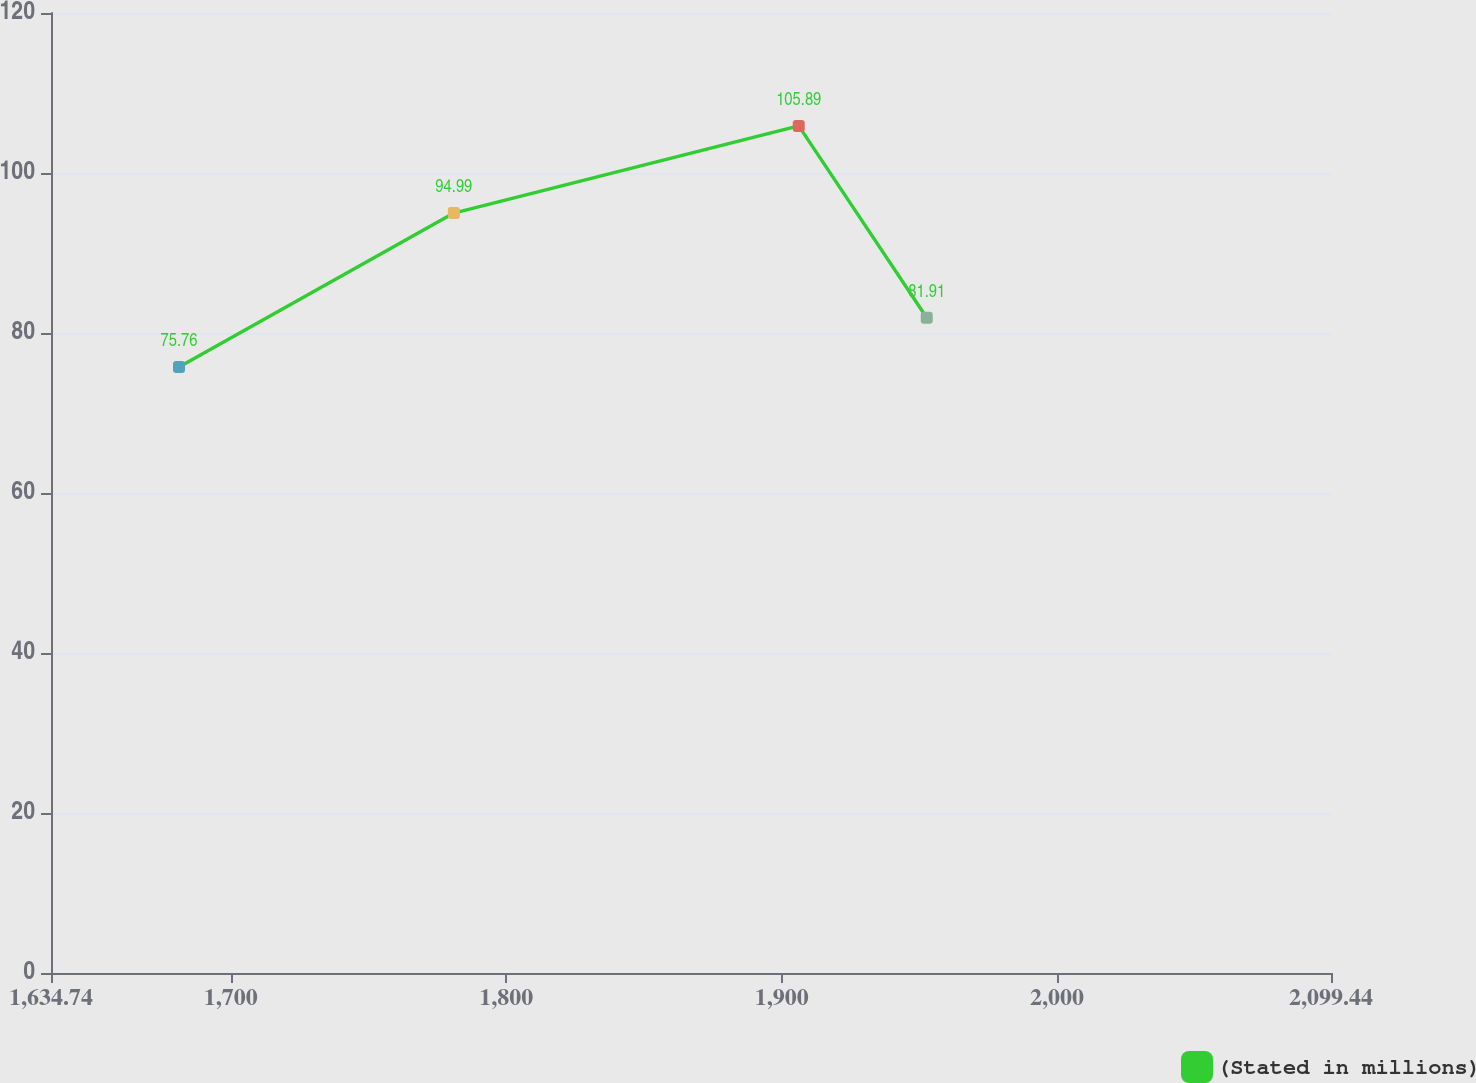Convert chart to OTSL. <chart><loc_0><loc_0><loc_500><loc_500><line_chart><ecel><fcel>(Stated in millions)<nl><fcel>1681.21<fcel>75.76<nl><fcel>1780.99<fcel>94.99<nl><fcel>1906.2<fcel>105.89<nl><fcel>1952.67<fcel>81.91<nl><fcel>2145.91<fcel>109.69<nl></chart> 